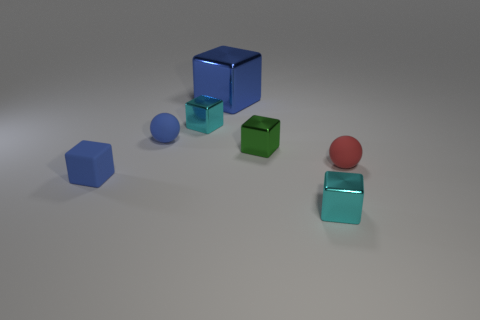Is the number of blue metallic objects behind the tiny green cube less than the number of blue rubber spheres?
Provide a succinct answer. No. How many big blue blocks are behind the tiny ball that is on the left side of the red thing?
Offer a very short reply. 1. How many other objects are there of the same size as the blue sphere?
Ensure brevity in your answer.  5. How many objects are small blue cubes or tiny matte balls in front of the green shiny object?
Keep it short and to the point. 2. Is the number of tiny green shiny cubes less than the number of small blue rubber cylinders?
Provide a short and direct response. No. What color is the sphere to the right of the tiny cyan metal cube in front of the rubber block?
Give a very brief answer. Red. What is the material of the tiny green object that is the same shape as the big object?
Keep it short and to the point. Metal. What number of matte things are either small balls or cyan cubes?
Your answer should be compact. 2. Is the cyan block in front of the blue rubber cube made of the same material as the blue block behind the red matte thing?
Your answer should be very brief. Yes. Are there any small matte balls?
Offer a very short reply. Yes. 